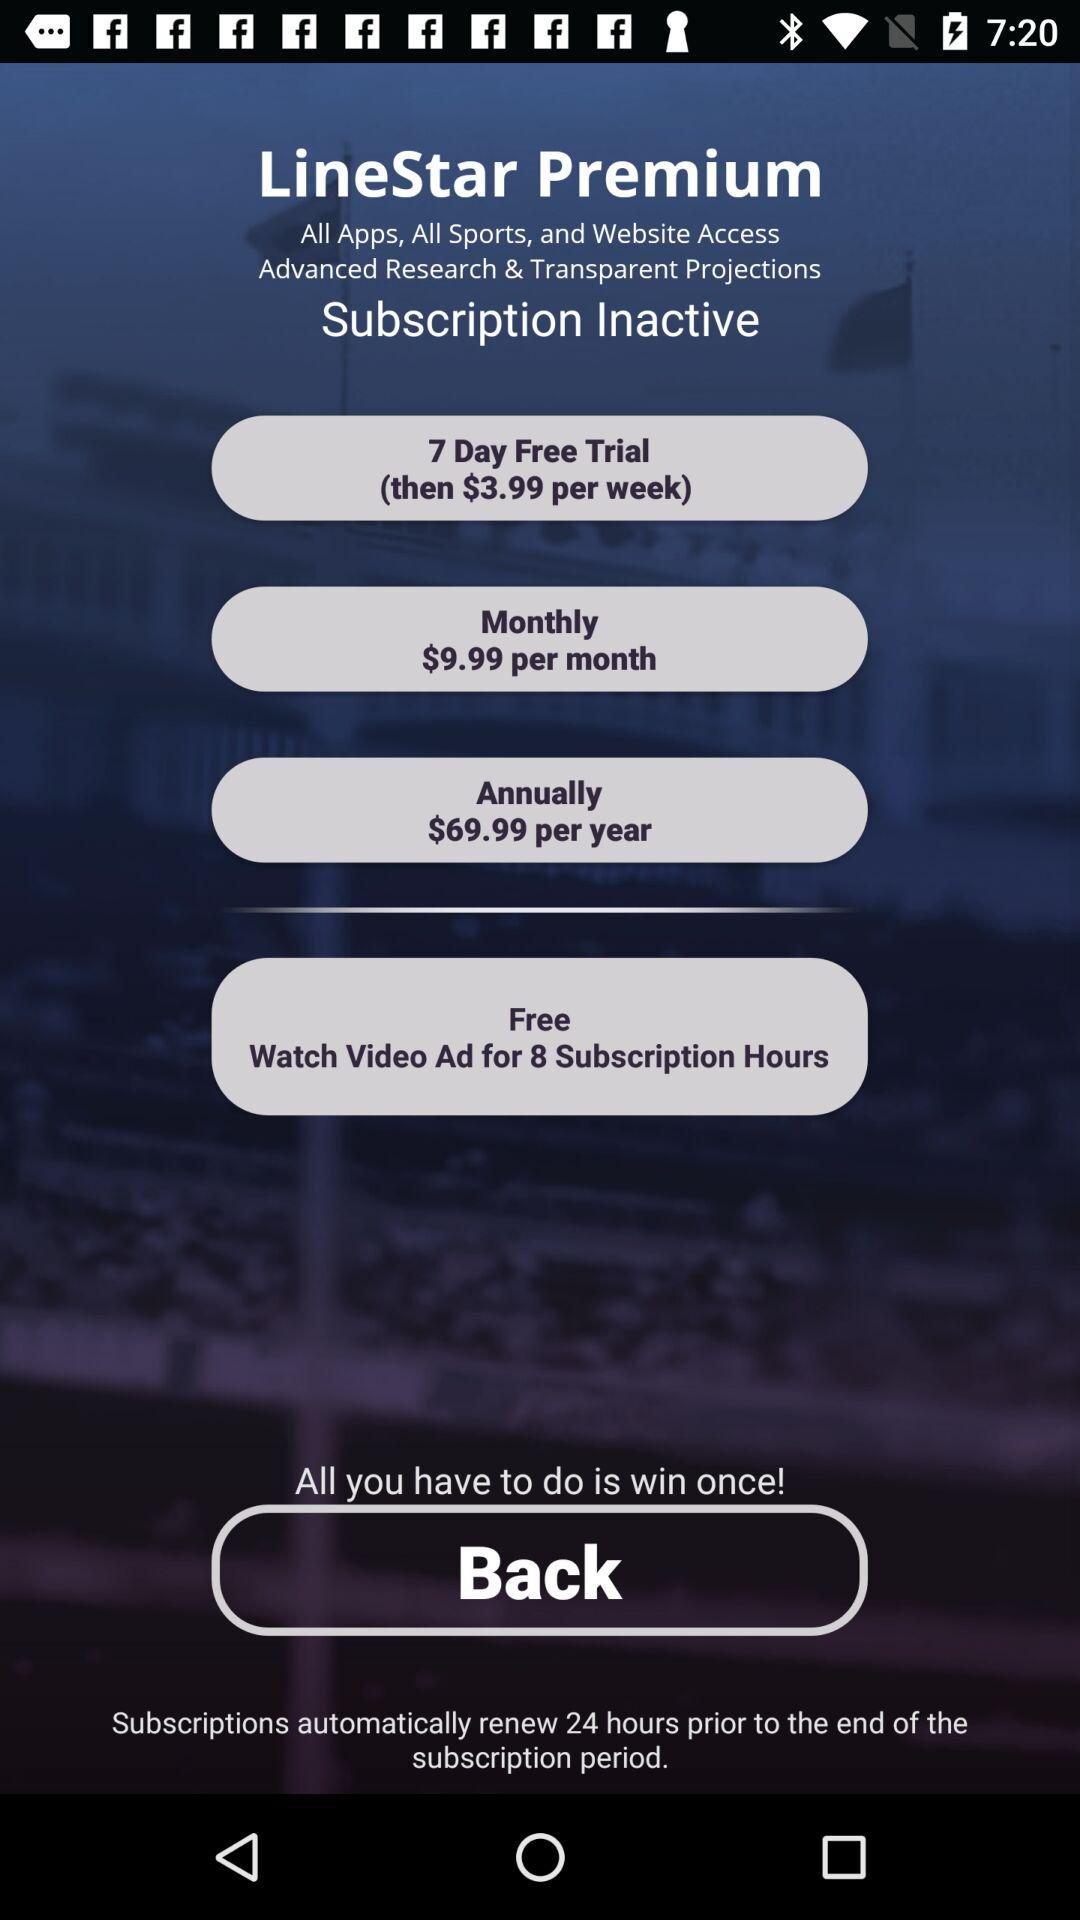How many hours of subscription time can I get for free by watching a video ad?
Answer the question using a single word or phrase. 8 